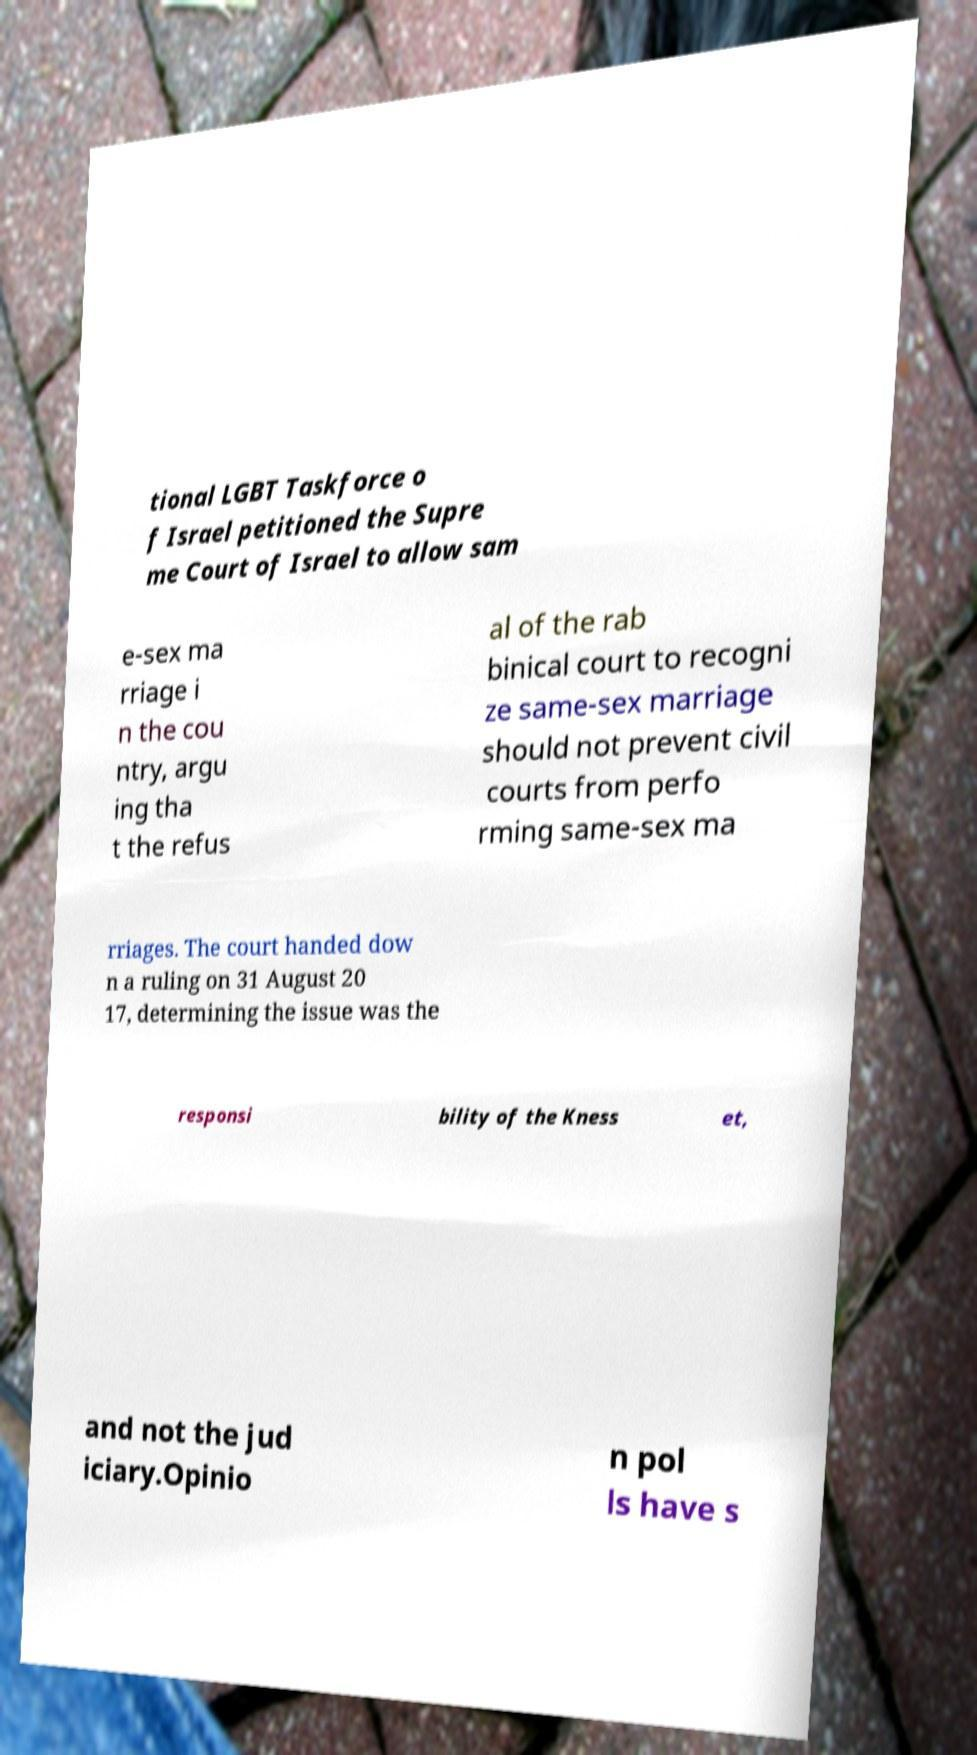Can you read and provide the text displayed in the image?This photo seems to have some interesting text. Can you extract and type it out for me? tional LGBT Taskforce o f Israel petitioned the Supre me Court of Israel to allow sam e-sex ma rriage i n the cou ntry, argu ing tha t the refus al of the rab binical court to recogni ze same-sex marriage should not prevent civil courts from perfo rming same-sex ma rriages. The court handed dow n a ruling on 31 August 20 17, determining the issue was the responsi bility of the Kness et, and not the jud iciary.Opinio n pol ls have s 